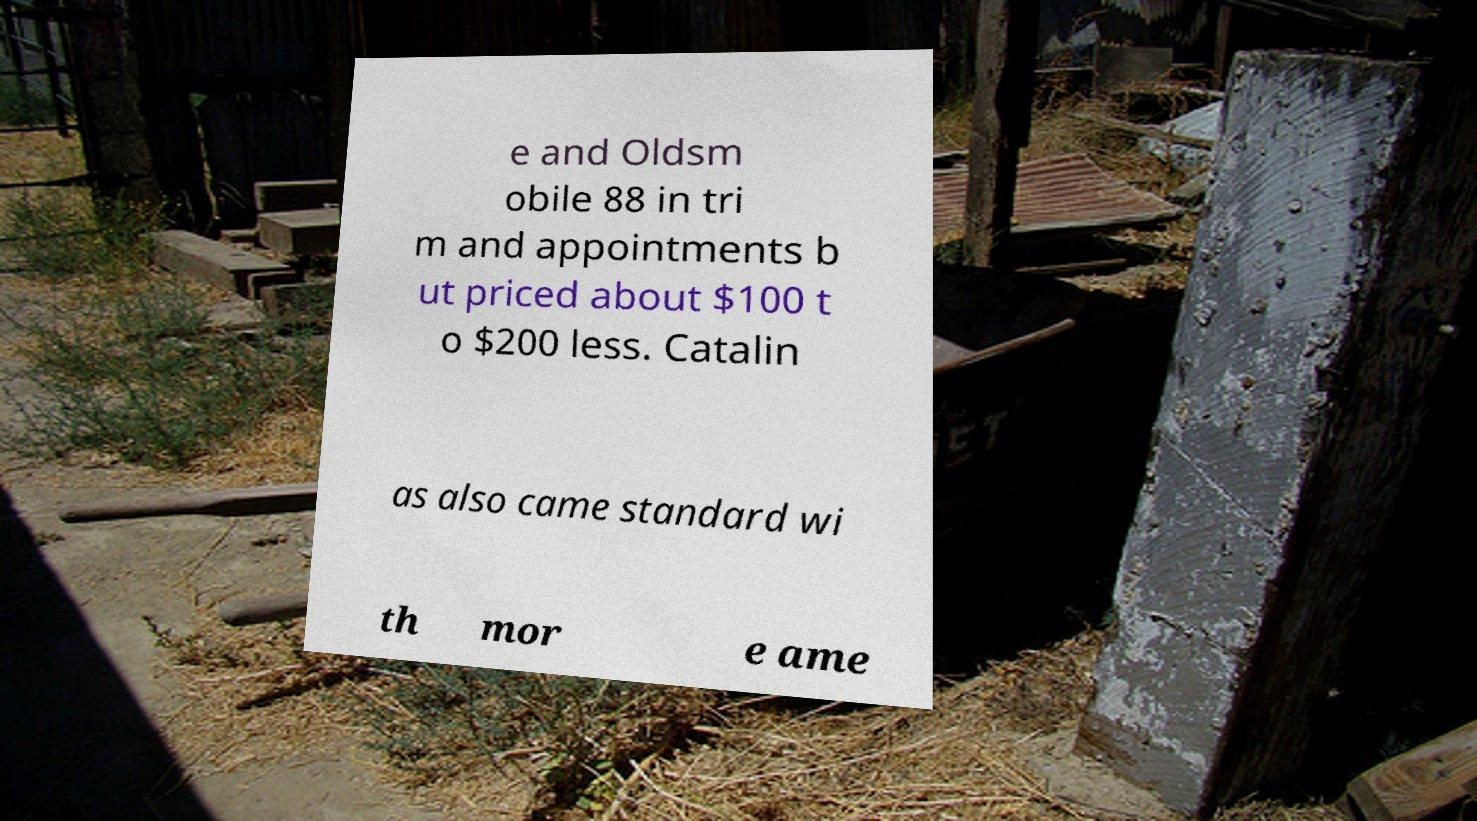Please identify and transcribe the text found in this image. e and Oldsm obile 88 in tri m and appointments b ut priced about $100 t o $200 less. Catalin as also came standard wi th mor e ame 